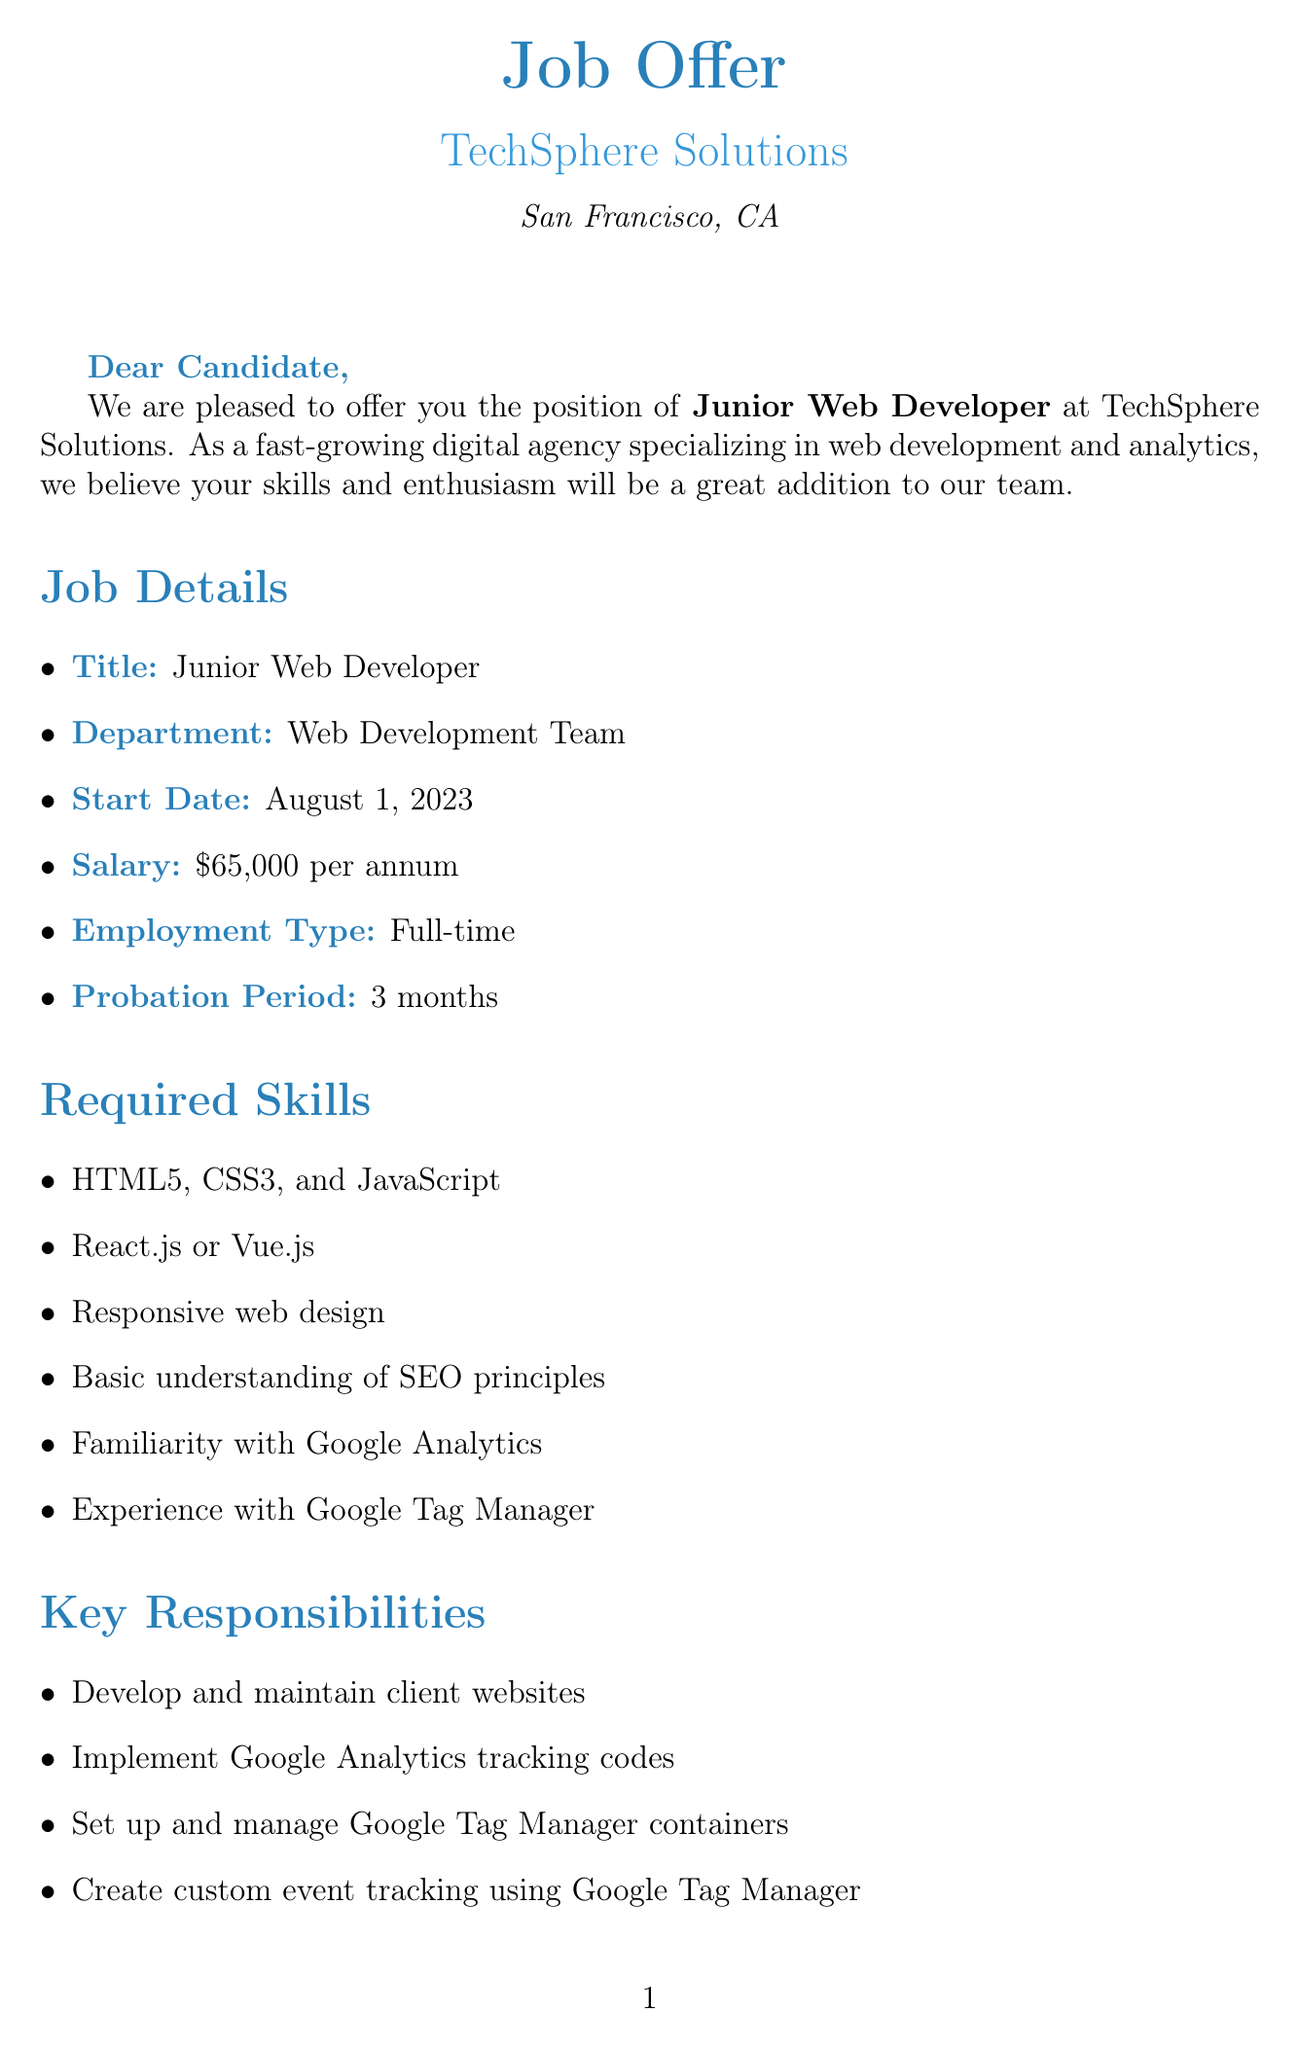what is the job title? The job title specified in the document is Junior Web Developer.
Answer: Junior Web Developer what is the start date? The start date for the position as mentioned is August 1, 2023.
Answer: August 1, 2023 what is the annual salary? The annual salary for the position stated in the document is $65,000 per annum.
Answer: $65,000 per annum how long is the probation period? The probation period mentioned in the document is 3 months.
Answer: 3 months which frameworks are required? The document specifies React.js or Vue.js as required frameworks for the position.
Answer: React.js or Vue.js who is the hiring manager? The hiring manager's name listed in the document is Sarah Thompson.
Answer: Sarah Thompson what type of employment is offered? The document states that the employment type is Full-time.
Answer: Full-time what is the team size? The team size mentioned in the document is 15 developers.
Answer: 15 developers what benefit supports professional development? The document indicates that there is Google Analytics Individual Qualification certification support as a benefit.
Answer: Google Analytics Individual Qualification certification support 